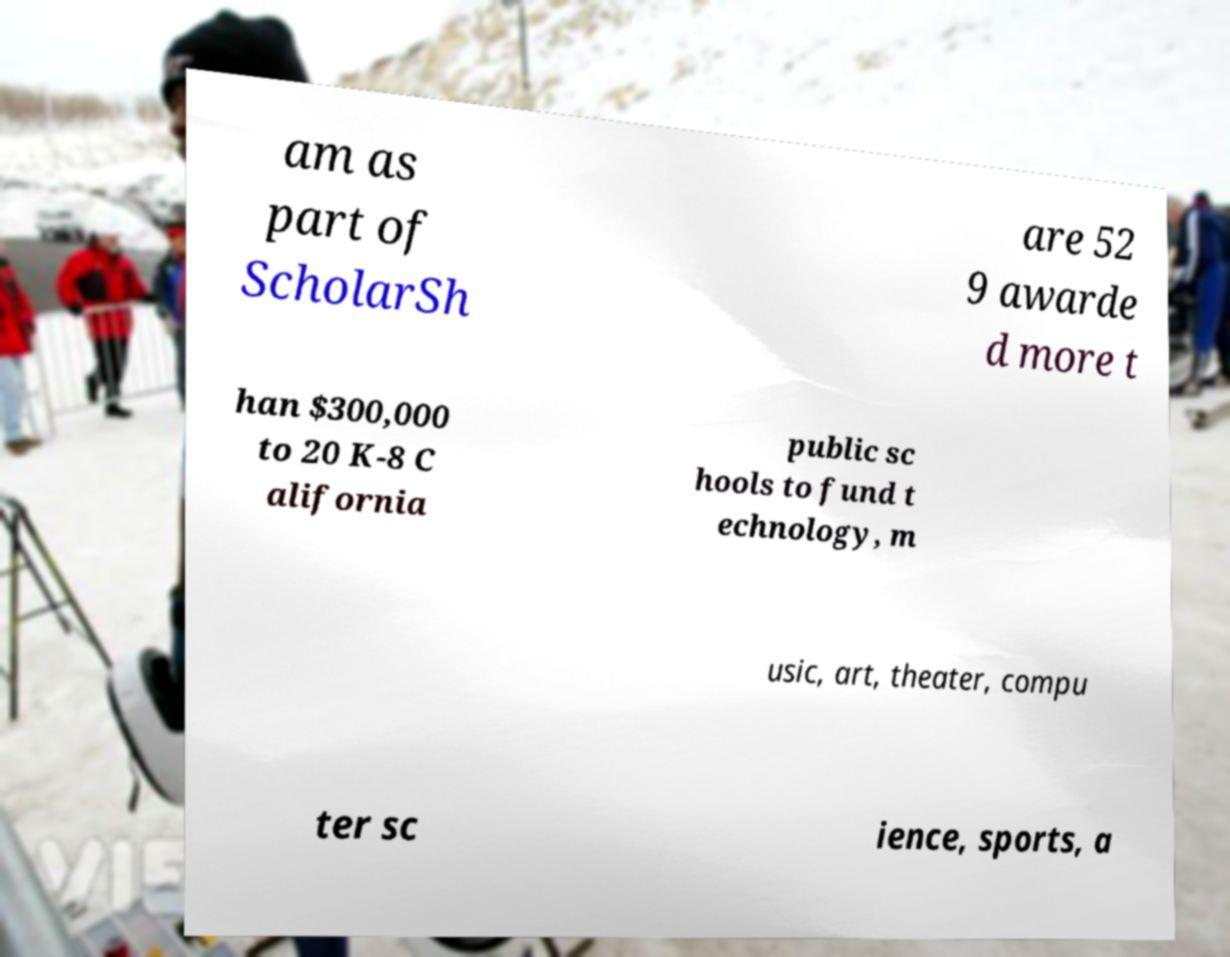Please read and relay the text visible in this image. What does it say? am as part of ScholarSh are 52 9 awarde d more t han $300,000 to 20 K-8 C alifornia public sc hools to fund t echnology, m usic, art, theater, compu ter sc ience, sports, a 